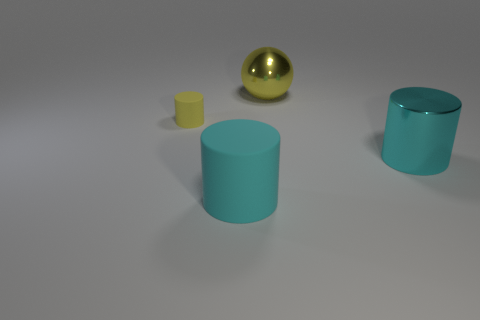Can you tell what time of day it appears to be in this image based on the lighting? Although it's difficult to determine the exact time of day from an indoor lighting environment, the neutral lighting suggests it could be replicating standard daylight conditions. 